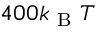<formula> <loc_0><loc_0><loc_500><loc_500>4 0 0 k _ { B } T</formula> 